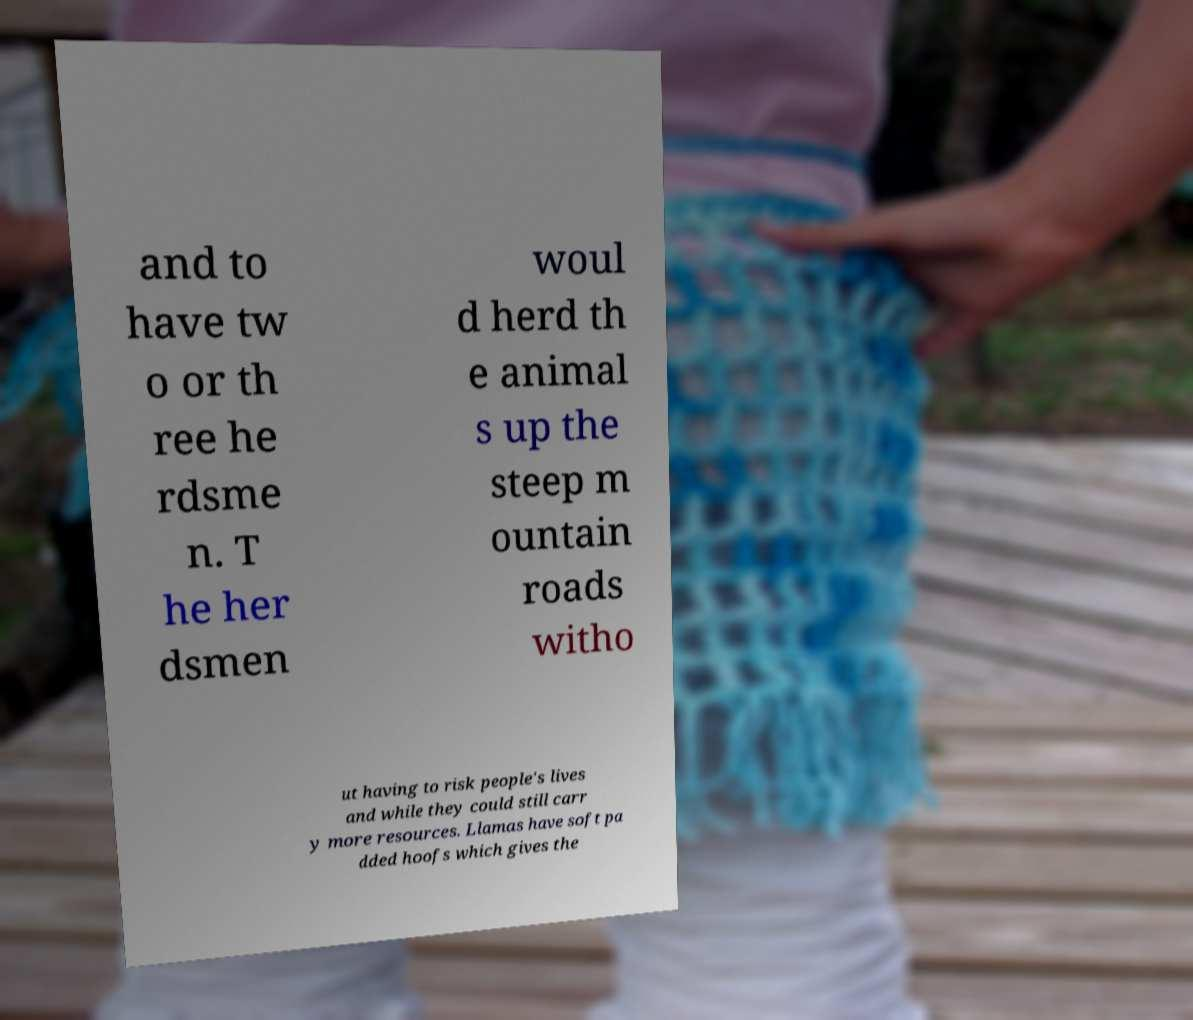Can you read and provide the text displayed in the image?This photo seems to have some interesting text. Can you extract and type it out for me? and to have tw o or th ree he rdsme n. T he her dsmen woul d herd th e animal s up the steep m ountain roads witho ut having to risk people's lives and while they could still carr y more resources. Llamas have soft pa dded hoofs which gives the 